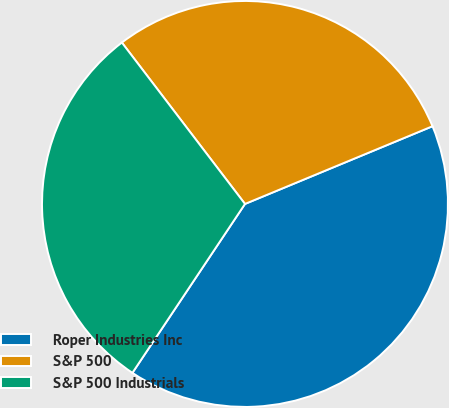Convert chart to OTSL. <chart><loc_0><loc_0><loc_500><loc_500><pie_chart><fcel>Roper Industries Inc<fcel>S&P 500<fcel>S&P 500 Industrials<nl><fcel>40.61%<fcel>29.12%<fcel>30.27%<nl></chart> 